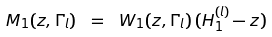Convert formula to latex. <formula><loc_0><loc_0><loc_500><loc_500>M _ { 1 } ( z , \Gamma _ { l } ) \ = \ W _ { 1 } ( z , \Gamma _ { l } ) \, ( H _ { 1 } ^ { ( l ) } - z ) \,</formula> 